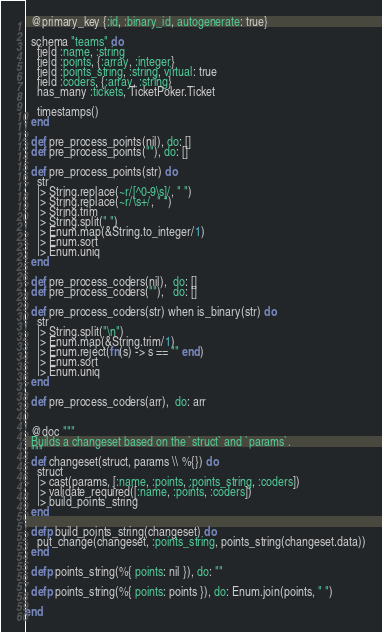<code> <loc_0><loc_0><loc_500><loc_500><_Elixir_>
  @primary_key {:id, :binary_id, autogenerate: true}

  schema "teams" do
    field :name, :string
    field :points, {:array, :integer}
    field :points_string, :string, virtual: true
    field :coders, {:array, :string}
    has_many :tickets, TicketPoker.Ticket

    timestamps()
  end

  def pre_process_points(nil), do: []
  def pre_process_points(""), do: []

  def pre_process_points(str) do
    str
    |> String.replace(~r/[^0-9\s]/, " ")
    |> String.replace(~r/\s+/, " ")
    |> String.trim
    |> String.split(" ")
    |> Enum.map(&String.to_integer/1)
    |> Enum.sort
    |> Enum.uniq
  end

  def pre_process_coders(nil),  do: []
  def pre_process_coders(""),   do: []

  def pre_process_coders(str) when is_binary(str) do
    str
    |> String.split("\n")
    |> Enum.map(&String.trim/1)
    |> Enum.reject(fn(s) -> s == "" end)
    |> Enum.sort
    |> Enum.uniq
  end

  def pre_process_coders(arr),  do: arr


  @doc """
  Builds a changeset based on the `struct` and `params`.
  """
  def changeset(struct, params \\ %{}) do
    struct
    |> cast(params, [:name, :points, :points_string, :coders])
    |> validate_required([:name, :points, :coders])
    |> build_points_string
  end

  defp build_points_string(changeset) do
    put_change(changeset, :points_string, points_string(changeset.data))
  end

  defp points_string(%{ points: nil }), do: ""

  defp points_string(%{ points: points }), do: Enum.join(points, " ")

end
</code> 